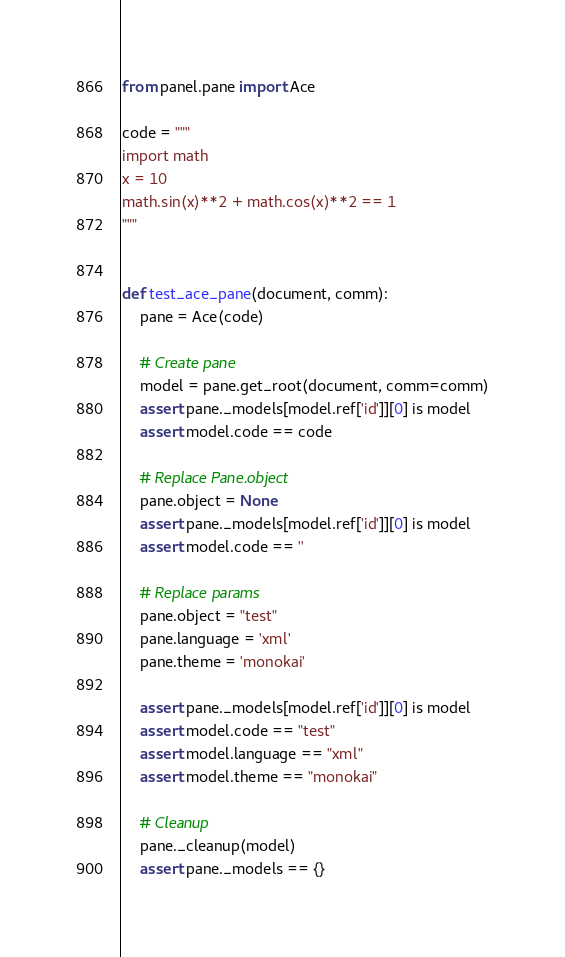Convert code to text. <code><loc_0><loc_0><loc_500><loc_500><_Python_>from panel.pane import Ace

code = """
import math
x = 10
math.sin(x)**2 + math.cos(x)**2 == 1
"""


def test_ace_pane(document, comm):
    pane = Ace(code)

    # Create pane
    model = pane.get_root(document, comm=comm)
    assert pane._models[model.ref['id']][0] is model
    assert model.code == code

    # Replace Pane.object
    pane.object = None
    assert pane._models[model.ref['id']][0] is model
    assert model.code == ''

    # Replace params
    pane.object = "test"
    pane.language = 'xml'
    pane.theme = 'monokai'

    assert pane._models[model.ref['id']][0] is model
    assert model.code == "test"
    assert model.language == "xml"
    assert model.theme == "monokai"

    # Cleanup
    pane._cleanup(model)
    assert pane._models == {}
</code> 